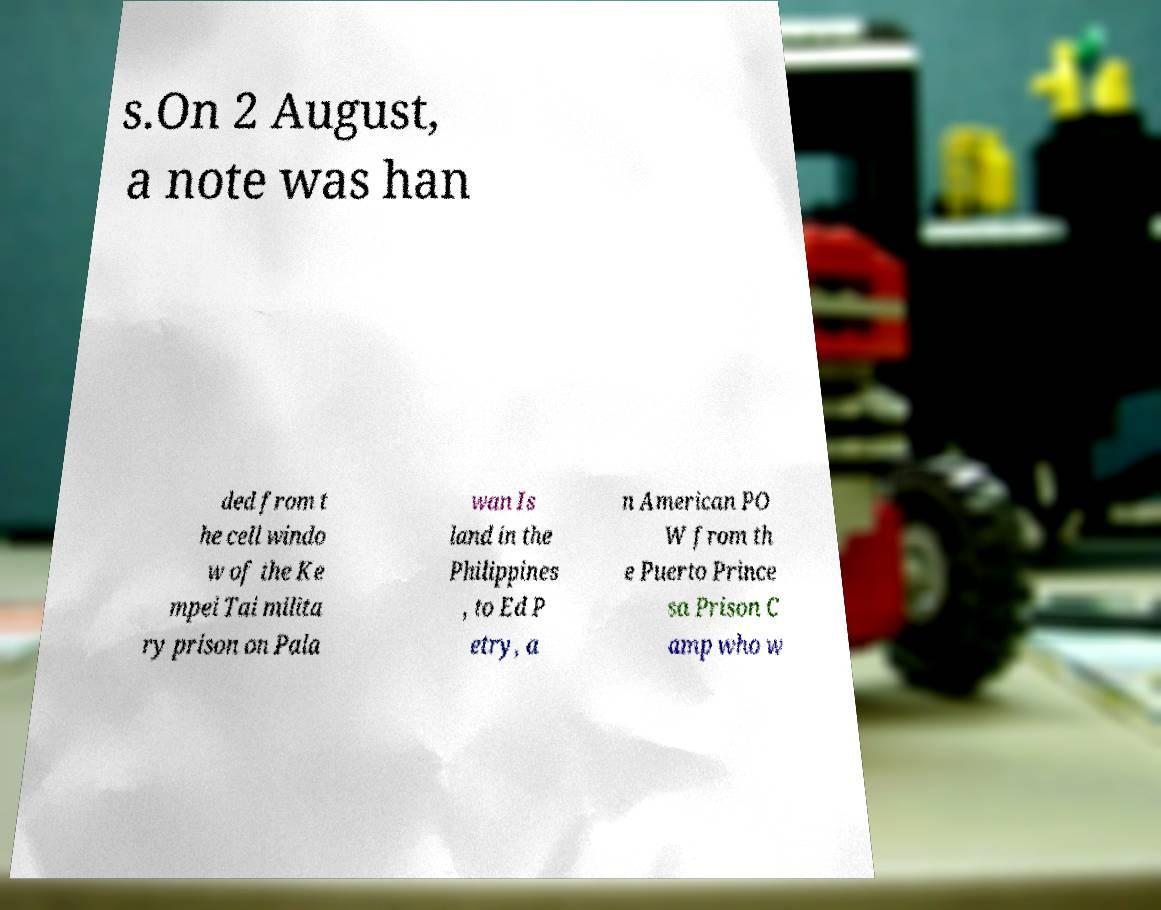I need the written content from this picture converted into text. Can you do that? s.On 2 August, a note was han ded from t he cell windo w of the Ke mpei Tai milita ry prison on Pala wan Is land in the Philippines , to Ed P etry, a n American PO W from th e Puerto Prince sa Prison C amp who w 